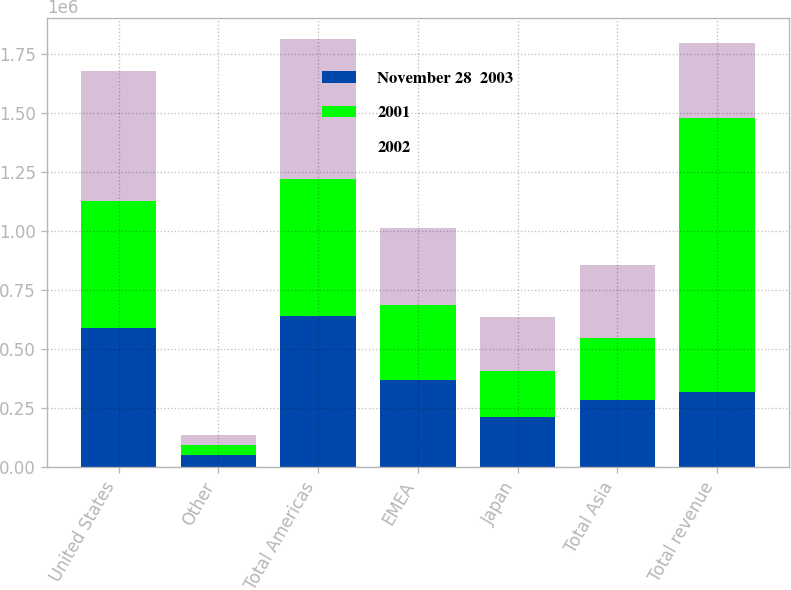Convert chart. <chart><loc_0><loc_0><loc_500><loc_500><stacked_bar_chart><ecel><fcel>United States<fcel>Other<fcel>Total Americas<fcel>EMEA<fcel>Japan<fcel>Total Asia<fcel>Total revenue<nl><fcel>November 28  2003<fcel>588631<fcel>51551<fcel>640182<fcel>370181<fcel>212505<fcel>284386<fcel>317638<nl><fcel>2001<fcel>541578<fcel>42176<fcel>583754<fcel>317638<fcel>195457<fcel>263396<fcel>1.16479e+06<nl><fcel>2002<fcel>547630<fcel>43878<fcel>591508<fcel>326499<fcel>228744<fcel>311713<fcel>317638<nl></chart> 